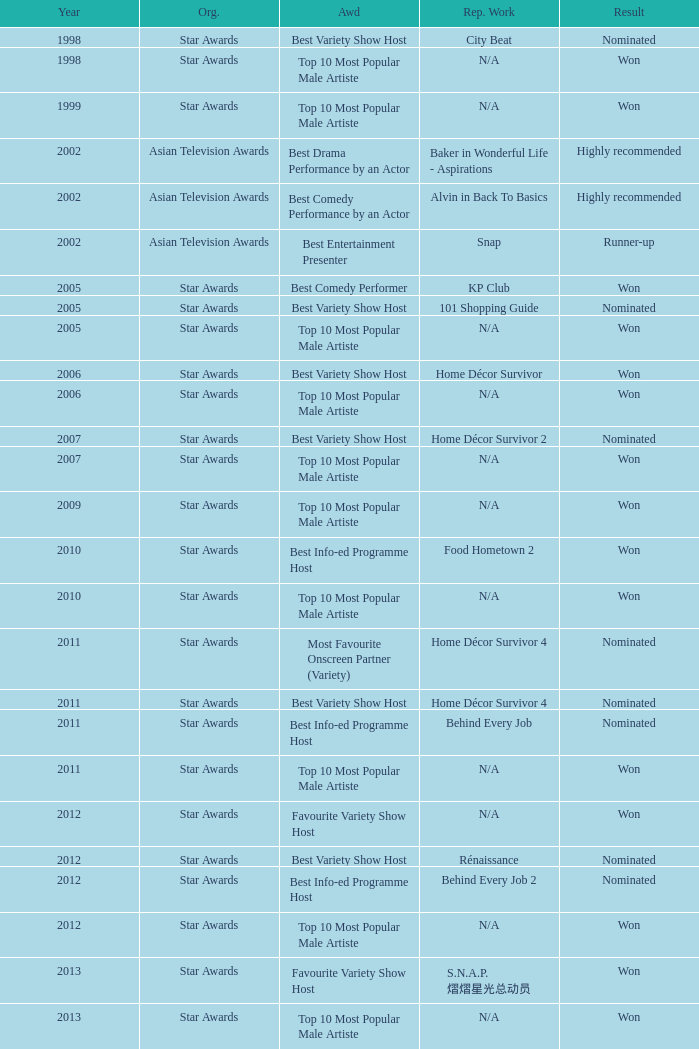What is the award for the Star Awards earlier than 2005 and the result is won? Top 10 Most Popular Male Artiste, Top 10 Most Popular Male Artiste. 